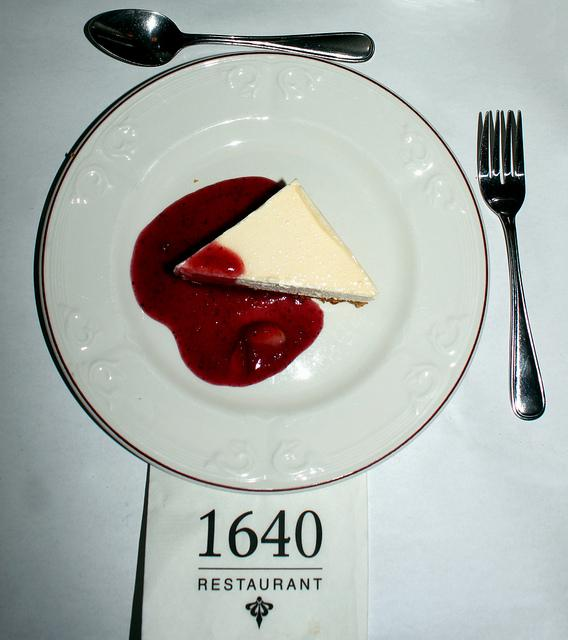What is on the plate?

Choices:
A) pear
B) apple
C) sausage
D) cake cake 